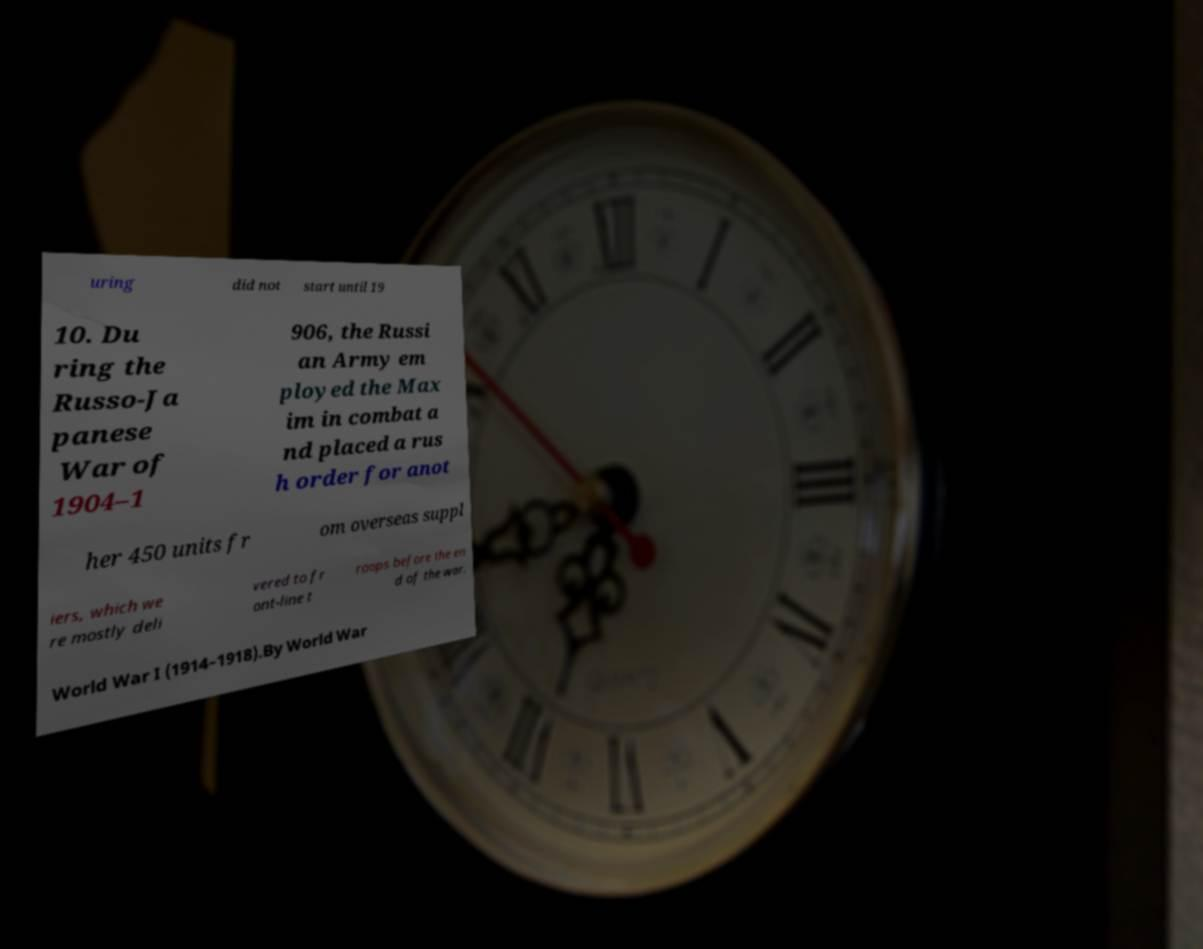Can you accurately transcribe the text from the provided image for me? uring did not start until 19 10. Du ring the Russo-Ja panese War of 1904–1 906, the Russi an Army em ployed the Max im in combat a nd placed a rus h order for anot her 450 units fr om overseas suppl iers, which we re mostly deli vered to fr ont-line t roops before the en d of the war. World War I (1914–1918).By World War 